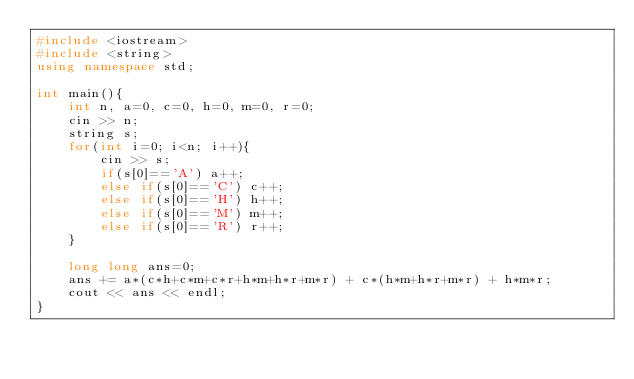<code> <loc_0><loc_0><loc_500><loc_500><_C++_>#include <iostream>
#include <string>
using namespace std;

int main(){
	int n, a=0, c=0, h=0, m=0, r=0;
	cin >> n;
	string s;
	for(int i=0; i<n; i++){
		cin >> s;
		if(s[0]=='A') a++;
		else if(s[0]=='C') c++;
		else if(s[0]=='H') h++;
		else if(s[0]=='M') m++;
		else if(s[0]=='R') r++;
	}

	long long ans=0;
	ans += a*(c*h+c*m+c*r+h*m+h*r+m*r) + c*(h*m+h*r+m*r) + h*m*r;
	cout << ans << endl;
}</code> 